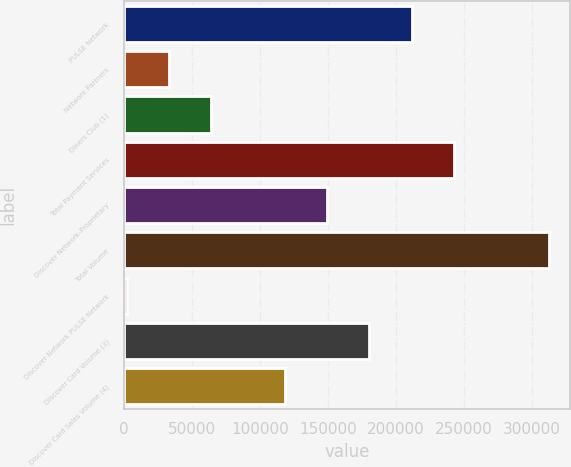<chart> <loc_0><loc_0><loc_500><loc_500><bar_chart><fcel>PULSE Network<fcel>Network Partners<fcel>Diners Club (1)<fcel>Total Payment Services<fcel>Discover Network-Proprietary<fcel>Total Volume<fcel>Discover Network PULSE Network<fcel>Discover Card Volume (3)<fcel>Discover Card Sales Volume (4)<nl><fcel>211553<fcel>33070<fcel>64107<fcel>242590<fcel>149479<fcel>312403<fcel>2033<fcel>180516<fcel>118442<nl></chart> 